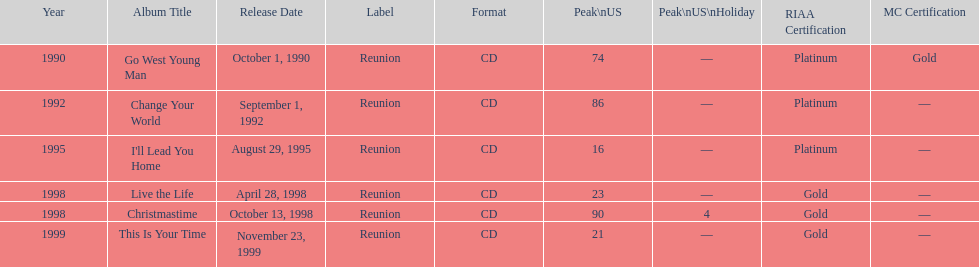How many album entries are there? 6. 